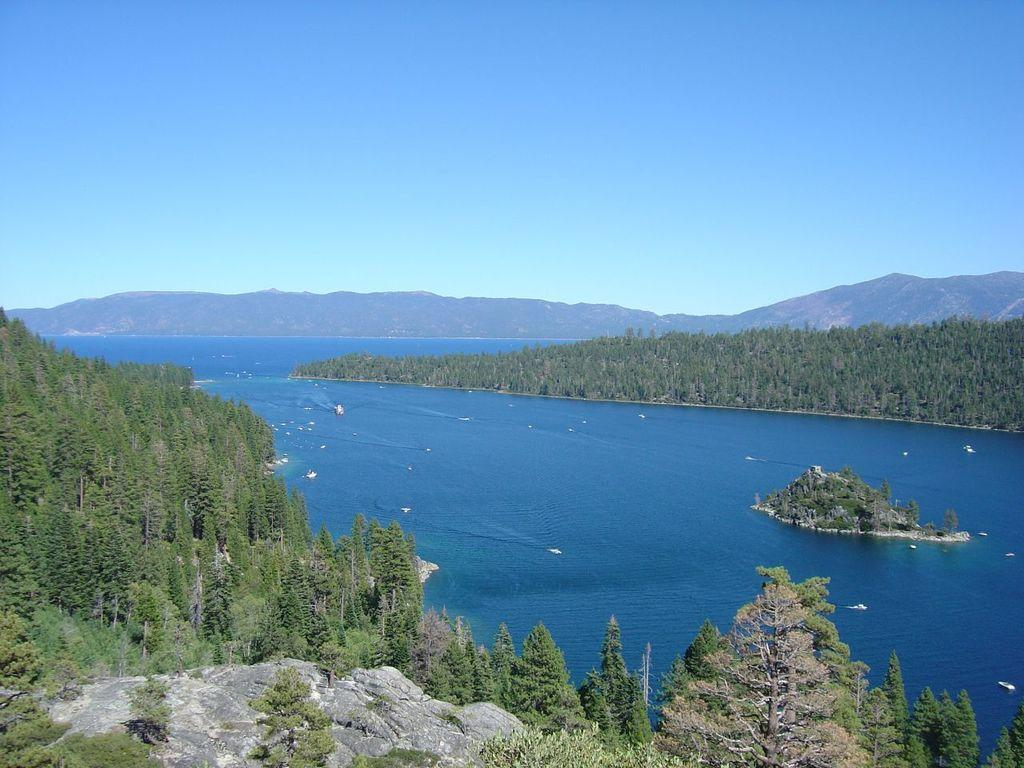What type of vegetation can be seen in the image? There are trees in the image. What is the color of the trees? The trees are green in color. What else can be seen in the image besides the trees? There is water visible in the image. What is visible in the background of the image? There are mountains in the background of the image. What is the color of the sky in the image? The sky is blue and white in color. Who gave the trees their haircut in the image? Trees do not have hair, so they cannot receive a haircut. The question is not relevant to the image. 